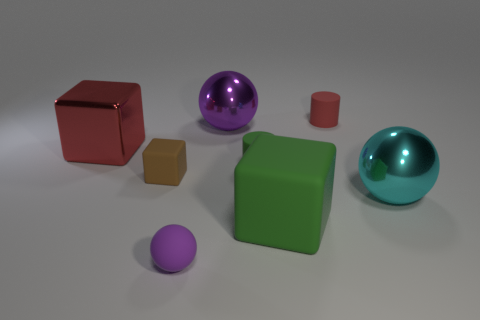Subtract all rubber balls. How many balls are left? 2 Subtract all purple balls. How many balls are left? 1 Subtract all spheres. How many objects are left? 5 Add 1 green cylinders. How many objects exist? 9 Subtract 1 purple balls. How many objects are left? 7 Subtract 1 blocks. How many blocks are left? 2 Subtract all blue cylinders. Subtract all blue balls. How many cylinders are left? 2 Subtract all red blocks. How many green spheres are left? 0 Subtract all tiny gray things. Subtract all large cyan metal things. How many objects are left? 7 Add 5 cyan spheres. How many cyan spheres are left? 6 